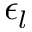<formula> <loc_0><loc_0><loc_500><loc_500>\epsilon _ { l }</formula> 